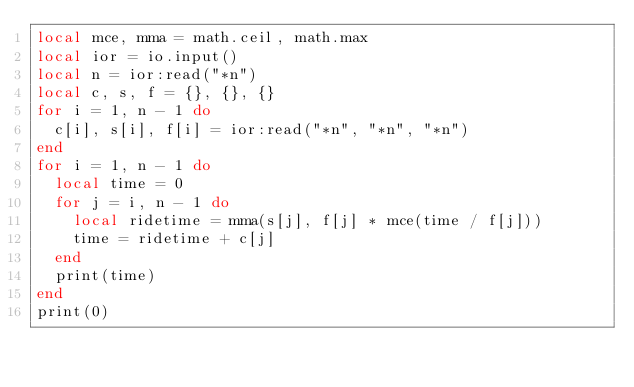<code> <loc_0><loc_0><loc_500><loc_500><_Lua_>local mce, mma = math.ceil, math.max
local ior = io.input()
local n = ior:read("*n")
local c, s, f = {}, {}, {}
for i = 1, n - 1 do
  c[i], s[i], f[i] = ior:read("*n", "*n", "*n")
end
for i = 1, n - 1 do
  local time = 0
  for j = i, n - 1 do
    local ridetime = mma(s[j], f[j] * mce(time / f[j]))
    time = ridetime + c[j]
  end
  print(time)
end
print(0)
</code> 